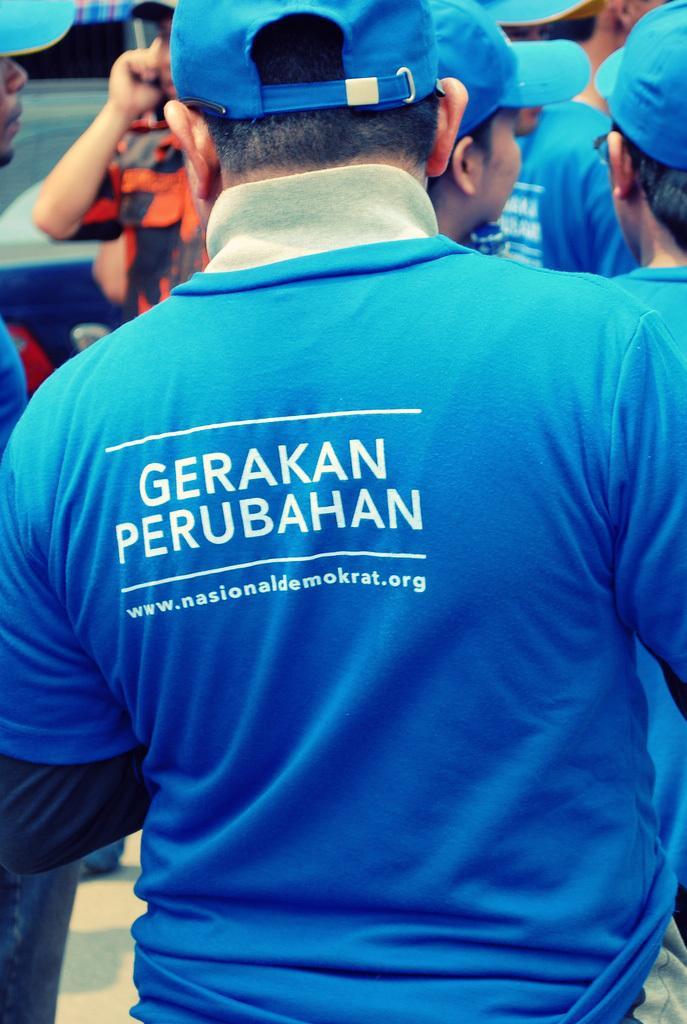Can you describe this image briefly? As we can see in the image there are group of people wearing blue color caps and blue color t shirts. 